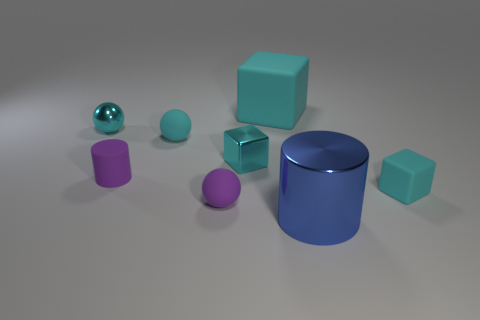How many other objects are there of the same color as the small metallic ball?
Offer a very short reply. 4. What is the shape of the object that is both right of the cyan shiny block and left of the large blue cylinder?
Your answer should be very brief. Cube. There is a large cyan block that is left of the big object that is in front of the purple cylinder; is there a large cyan cube that is on the left side of it?
Provide a succinct answer. No. How many other objects are the same material as the big blue thing?
Offer a very short reply. 2. How many tiny brown matte balls are there?
Offer a very short reply. 0. What number of things are large matte things or cyan objects that are to the right of the small cyan metallic sphere?
Offer a terse response. 4. Are there any other things that are the same shape as the large matte thing?
Provide a short and direct response. Yes. Do the cylinder that is to the right of the cyan rubber sphere and the big cyan rubber cube have the same size?
Offer a very short reply. Yes. What number of metallic things are yellow cylinders or small cyan spheres?
Provide a succinct answer. 1. There is a cyan metal thing to the right of the purple cylinder; what size is it?
Ensure brevity in your answer.  Small. 